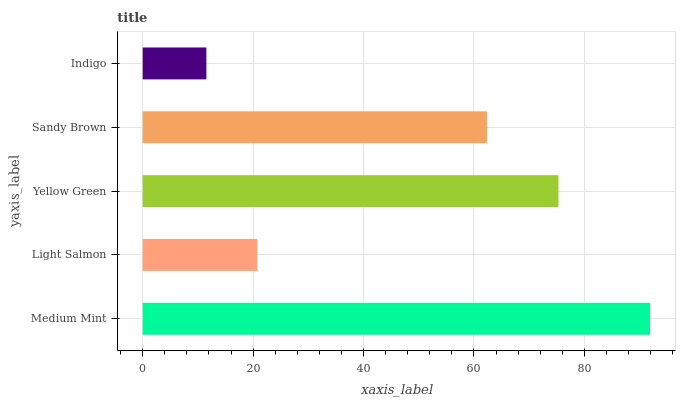Is Indigo the minimum?
Answer yes or no. Yes. Is Medium Mint the maximum?
Answer yes or no. Yes. Is Light Salmon the minimum?
Answer yes or no. No. Is Light Salmon the maximum?
Answer yes or no. No. Is Medium Mint greater than Light Salmon?
Answer yes or no. Yes. Is Light Salmon less than Medium Mint?
Answer yes or no. Yes. Is Light Salmon greater than Medium Mint?
Answer yes or no. No. Is Medium Mint less than Light Salmon?
Answer yes or no. No. Is Sandy Brown the high median?
Answer yes or no. Yes. Is Sandy Brown the low median?
Answer yes or no. Yes. Is Indigo the high median?
Answer yes or no. No. Is Medium Mint the low median?
Answer yes or no. No. 